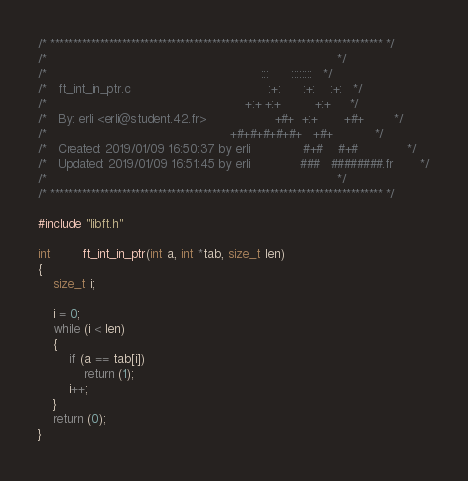<code> <loc_0><loc_0><loc_500><loc_500><_C_>/* ************************************************************************** */
/*                                                                            */
/*                                                        :::      ::::::::   */
/*   ft_int_in_ptr.c                                    :+:      :+:    :+:   */
/*                                                    +:+ +:+         +:+     */
/*   By: erli <erli@student.42.fr>                  +#+  +:+       +#+        */
/*                                                +#+#+#+#+#+   +#+           */
/*   Created: 2019/01/09 16:50:37 by erli              #+#    #+#             */
/*   Updated: 2019/01/09 16:51:45 by erli             ###   ########.fr       */
/*                                                                            */
/* ************************************************************************** */

#include "libft.h"

int		ft_int_in_ptr(int a, int *tab, size_t len)
{
	size_t i;

	i = 0;
	while (i < len)
	{
		if (a == tab[i])
			return (1);
		i++;
	}
	return (0);
}
</code> 